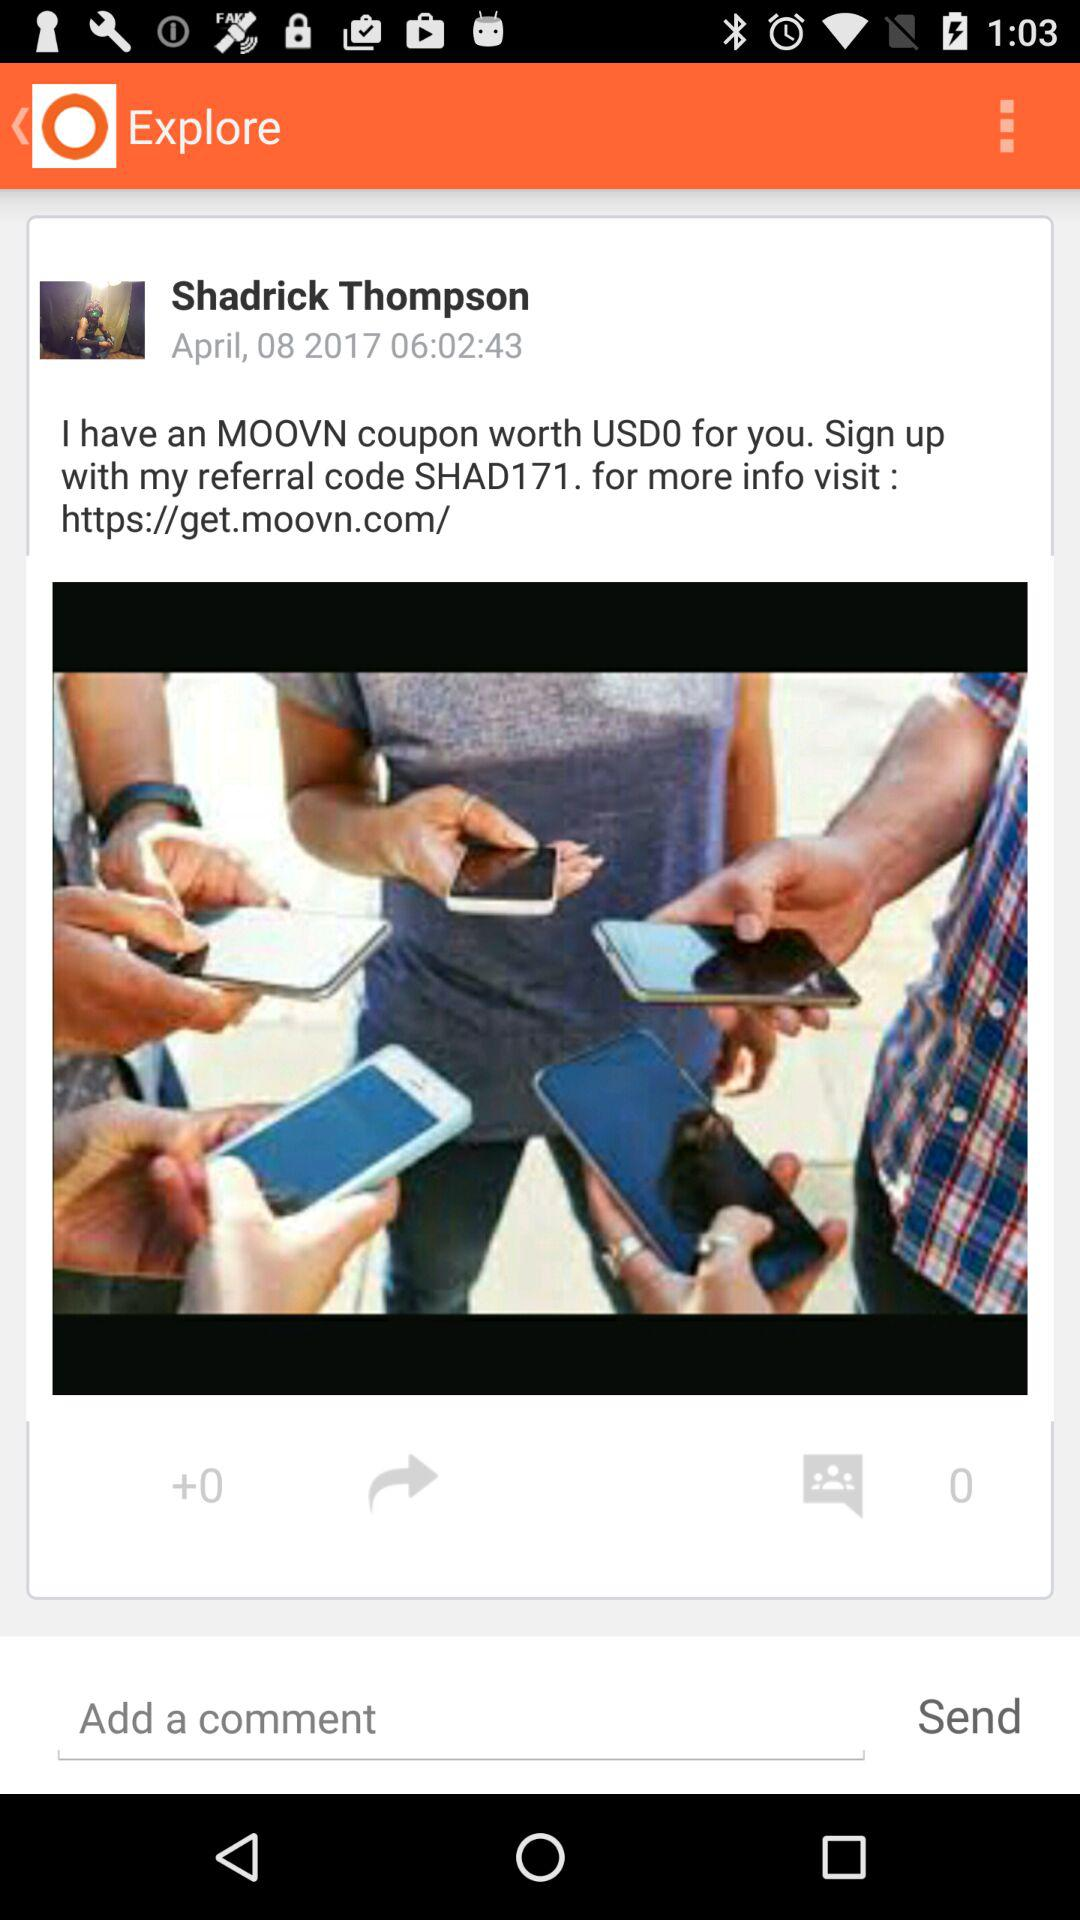What is the user name? The user name is Shadrick Thompson. 